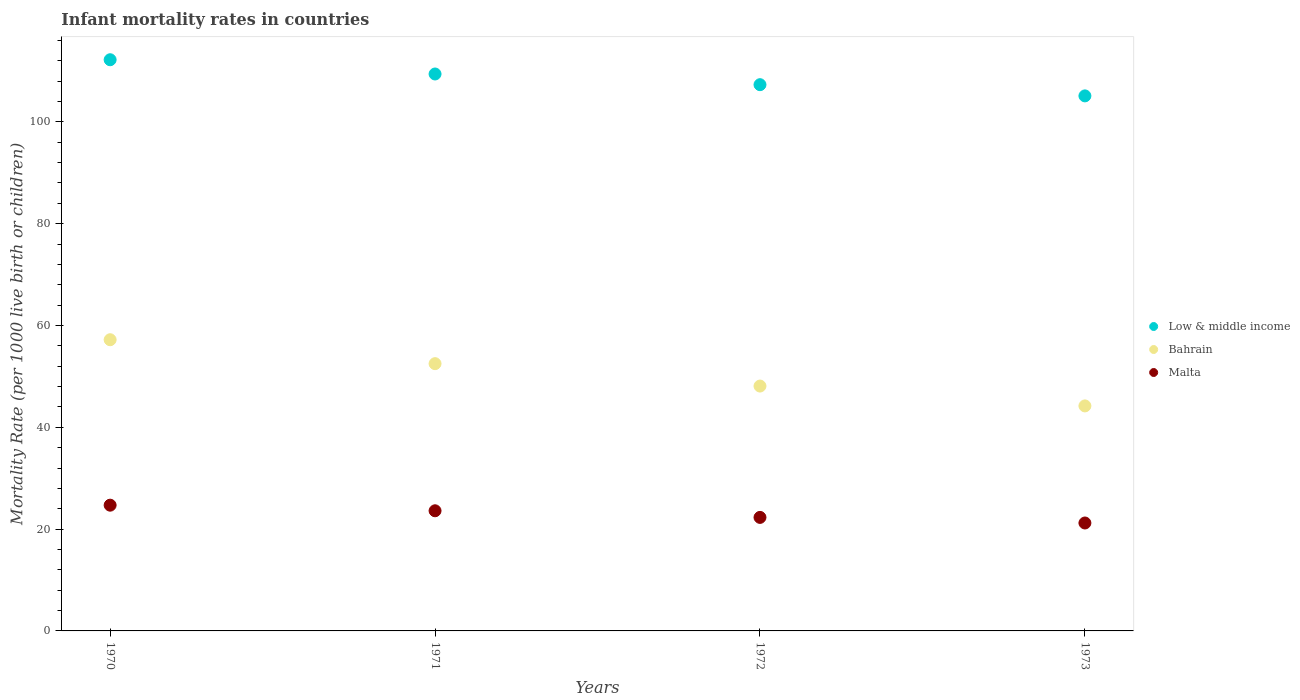How many different coloured dotlines are there?
Provide a short and direct response. 3. What is the infant mortality rate in Low & middle income in 1971?
Provide a succinct answer. 109.4. Across all years, what is the maximum infant mortality rate in Bahrain?
Your answer should be compact. 57.2. Across all years, what is the minimum infant mortality rate in Low & middle income?
Give a very brief answer. 105.1. In which year was the infant mortality rate in Low & middle income maximum?
Give a very brief answer. 1970. What is the total infant mortality rate in Low & middle income in the graph?
Your answer should be very brief. 434. What is the difference between the infant mortality rate in Malta in 1970 and that in 1972?
Make the answer very short. 2.4. What is the difference between the infant mortality rate in Bahrain in 1973 and the infant mortality rate in Malta in 1972?
Give a very brief answer. 21.9. What is the average infant mortality rate in Malta per year?
Offer a very short reply. 22.95. In the year 1973, what is the difference between the infant mortality rate in Low & middle income and infant mortality rate in Malta?
Provide a succinct answer. 83.9. What is the ratio of the infant mortality rate in Low & middle income in 1970 to that in 1971?
Offer a terse response. 1.03. Is the infant mortality rate in Low & middle income in 1971 less than that in 1972?
Ensure brevity in your answer.  No. Is the difference between the infant mortality rate in Low & middle income in 1970 and 1971 greater than the difference between the infant mortality rate in Malta in 1970 and 1971?
Provide a short and direct response. Yes. What is the difference between the highest and the second highest infant mortality rate in Malta?
Give a very brief answer. 1.1. What is the difference between the highest and the lowest infant mortality rate in Malta?
Offer a terse response. 3.5. In how many years, is the infant mortality rate in Low & middle income greater than the average infant mortality rate in Low & middle income taken over all years?
Provide a succinct answer. 2. Does the infant mortality rate in Malta monotonically increase over the years?
Provide a short and direct response. No. Is the infant mortality rate in Low & middle income strictly greater than the infant mortality rate in Malta over the years?
Give a very brief answer. Yes. Is the infant mortality rate in Bahrain strictly less than the infant mortality rate in Malta over the years?
Your answer should be compact. No. How many years are there in the graph?
Make the answer very short. 4. What is the difference between two consecutive major ticks on the Y-axis?
Offer a very short reply. 20. Does the graph contain any zero values?
Your answer should be very brief. No. Does the graph contain grids?
Give a very brief answer. No. What is the title of the graph?
Keep it short and to the point. Infant mortality rates in countries. What is the label or title of the Y-axis?
Give a very brief answer. Mortality Rate (per 1000 live birth or children). What is the Mortality Rate (per 1000 live birth or children) in Low & middle income in 1970?
Provide a short and direct response. 112.2. What is the Mortality Rate (per 1000 live birth or children) in Bahrain in 1970?
Your answer should be compact. 57.2. What is the Mortality Rate (per 1000 live birth or children) in Malta in 1970?
Provide a short and direct response. 24.7. What is the Mortality Rate (per 1000 live birth or children) of Low & middle income in 1971?
Your answer should be compact. 109.4. What is the Mortality Rate (per 1000 live birth or children) in Bahrain in 1971?
Provide a short and direct response. 52.5. What is the Mortality Rate (per 1000 live birth or children) in Malta in 1971?
Provide a short and direct response. 23.6. What is the Mortality Rate (per 1000 live birth or children) of Low & middle income in 1972?
Provide a succinct answer. 107.3. What is the Mortality Rate (per 1000 live birth or children) in Bahrain in 1972?
Offer a very short reply. 48.1. What is the Mortality Rate (per 1000 live birth or children) in Malta in 1972?
Your response must be concise. 22.3. What is the Mortality Rate (per 1000 live birth or children) of Low & middle income in 1973?
Keep it short and to the point. 105.1. What is the Mortality Rate (per 1000 live birth or children) in Bahrain in 1973?
Provide a succinct answer. 44.2. What is the Mortality Rate (per 1000 live birth or children) in Malta in 1973?
Keep it short and to the point. 21.2. Across all years, what is the maximum Mortality Rate (per 1000 live birth or children) of Low & middle income?
Offer a very short reply. 112.2. Across all years, what is the maximum Mortality Rate (per 1000 live birth or children) in Bahrain?
Keep it short and to the point. 57.2. Across all years, what is the maximum Mortality Rate (per 1000 live birth or children) of Malta?
Provide a short and direct response. 24.7. Across all years, what is the minimum Mortality Rate (per 1000 live birth or children) in Low & middle income?
Ensure brevity in your answer.  105.1. Across all years, what is the minimum Mortality Rate (per 1000 live birth or children) in Bahrain?
Your response must be concise. 44.2. Across all years, what is the minimum Mortality Rate (per 1000 live birth or children) of Malta?
Your answer should be compact. 21.2. What is the total Mortality Rate (per 1000 live birth or children) of Low & middle income in the graph?
Provide a succinct answer. 434. What is the total Mortality Rate (per 1000 live birth or children) in Bahrain in the graph?
Your answer should be compact. 202. What is the total Mortality Rate (per 1000 live birth or children) of Malta in the graph?
Give a very brief answer. 91.8. What is the difference between the Mortality Rate (per 1000 live birth or children) in Bahrain in 1970 and that in 1971?
Your answer should be compact. 4.7. What is the difference between the Mortality Rate (per 1000 live birth or children) in Low & middle income in 1970 and that in 1972?
Your response must be concise. 4.9. What is the difference between the Mortality Rate (per 1000 live birth or children) of Malta in 1970 and that in 1972?
Give a very brief answer. 2.4. What is the difference between the Mortality Rate (per 1000 live birth or children) in Low & middle income in 1970 and that in 1973?
Give a very brief answer. 7.1. What is the difference between the Mortality Rate (per 1000 live birth or children) in Bahrain in 1970 and that in 1973?
Your answer should be very brief. 13. What is the difference between the Mortality Rate (per 1000 live birth or children) in Malta in 1970 and that in 1973?
Offer a very short reply. 3.5. What is the difference between the Mortality Rate (per 1000 live birth or children) in Low & middle income in 1971 and that in 1972?
Your answer should be very brief. 2.1. What is the difference between the Mortality Rate (per 1000 live birth or children) of Bahrain in 1971 and that in 1972?
Offer a very short reply. 4.4. What is the difference between the Mortality Rate (per 1000 live birth or children) of Low & middle income in 1971 and that in 1973?
Provide a succinct answer. 4.3. What is the difference between the Mortality Rate (per 1000 live birth or children) of Malta in 1971 and that in 1973?
Your response must be concise. 2.4. What is the difference between the Mortality Rate (per 1000 live birth or children) of Low & middle income in 1972 and that in 1973?
Offer a very short reply. 2.2. What is the difference between the Mortality Rate (per 1000 live birth or children) in Malta in 1972 and that in 1973?
Provide a succinct answer. 1.1. What is the difference between the Mortality Rate (per 1000 live birth or children) of Low & middle income in 1970 and the Mortality Rate (per 1000 live birth or children) of Bahrain in 1971?
Your answer should be very brief. 59.7. What is the difference between the Mortality Rate (per 1000 live birth or children) of Low & middle income in 1970 and the Mortality Rate (per 1000 live birth or children) of Malta in 1971?
Offer a very short reply. 88.6. What is the difference between the Mortality Rate (per 1000 live birth or children) of Bahrain in 1970 and the Mortality Rate (per 1000 live birth or children) of Malta in 1971?
Provide a short and direct response. 33.6. What is the difference between the Mortality Rate (per 1000 live birth or children) in Low & middle income in 1970 and the Mortality Rate (per 1000 live birth or children) in Bahrain in 1972?
Keep it short and to the point. 64.1. What is the difference between the Mortality Rate (per 1000 live birth or children) of Low & middle income in 1970 and the Mortality Rate (per 1000 live birth or children) of Malta in 1972?
Give a very brief answer. 89.9. What is the difference between the Mortality Rate (per 1000 live birth or children) of Bahrain in 1970 and the Mortality Rate (per 1000 live birth or children) of Malta in 1972?
Offer a terse response. 34.9. What is the difference between the Mortality Rate (per 1000 live birth or children) of Low & middle income in 1970 and the Mortality Rate (per 1000 live birth or children) of Malta in 1973?
Provide a short and direct response. 91. What is the difference between the Mortality Rate (per 1000 live birth or children) in Bahrain in 1970 and the Mortality Rate (per 1000 live birth or children) in Malta in 1973?
Your answer should be compact. 36. What is the difference between the Mortality Rate (per 1000 live birth or children) in Low & middle income in 1971 and the Mortality Rate (per 1000 live birth or children) in Bahrain in 1972?
Your answer should be compact. 61.3. What is the difference between the Mortality Rate (per 1000 live birth or children) in Low & middle income in 1971 and the Mortality Rate (per 1000 live birth or children) in Malta in 1972?
Keep it short and to the point. 87.1. What is the difference between the Mortality Rate (per 1000 live birth or children) in Bahrain in 1971 and the Mortality Rate (per 1000 live birth or children) in Malta in 1972?
Your answer should be very brief. 30.2. What is the difference between the Mortality Rate (per 1000 live birth or children) in Low & middle income in 1971 and the Mortality Rate (per 1000 live birth or children) in Bahrain in 1973?
Provide a succinct answer. 65.2. What is the difference between the Mortality Rate (per 1000 live birth or children) in Low & middle income in 1971 and the Mortality Rate (per 1000 live birth or children) in Malta in 1973?
Your answer should be compact. 88.2. What is the difference between the Mortality Rate (per 1000 live birth or children) of Bahrain in 1971 and the Mortality Rate (per 1000 live birth or children) of Malta in 1973?
Ensure brevity in your answer.  31.3. What is the difference between the Mortality Rate (per 1000 live birth or children) of Low & middle income in 1972 and the Mortality Rate (per 1000 live birth or children) of Bahrain in 1973?
Make the answer very short. 63.1. What is the difference between the Mortality Rate (per 1000 live birth or children) in Low & middle income in 1972 and the Mortality Rate (per 1000 live birth or children) in Malta in 1973?
Ensure brevity in your answer.  86.1. What is the difference between the Mortality Rate (per 1000 live birth or children) in Bahrain in 1972 and the Mortality Rate (per 1000 live birth or children) in Malta in 1973?
Provide a short and direct response. 26.9. What is the average Mortality Rate (per 1000 live birth or children) of Low & middle income per year?
Make the answer very short. 108.5. What is the average Mortality Rate (per 1000 live birth or children) in Bahrain per year?
Offer a very short reply. 50.5. What is the average Mortality Rate (per 1000 live birth or children) in Malta per year?
Provide a succinct answer. 22.95. In the year 1970, what is the difference between the Mortality Rate (per 1000 live birth or children) in Low & middle income and Mortality Rate (per 1000 live birth or children) in Bahrain?
Give a very brief answer. 55. In the year 1970, what is the difference between the Mortality Rate (per 1000 live birth or children) of Low & middle income and Mortality Rate (per 1000 live birth or children) of Malta?
Your response must be concise. 87.5. In the year 1970, what is the difference between the Mortality Rate (per 1000 live birth or children) in Bahrain and Mortality Rate (per 1000 live birth or children) in Malta?
Provide a short and direct response. 32.5. In the year 1971, what is the difference between the Mortality Rate (per 1000 live birth or children) in Low & middle income and Mortality Rate (per 1000 live birth or children) in Bahrain?
Keep it short and to the point. 56.9. In the year 1971, what is the difference between the Mortality Rate (per 1000 live birth or children) of Low & middle income and Mortality Rate (per 1000 live birth or children) of Malta?
Your answer should be very brief. 85.8. In the year 1971, what is the difference between the Mortality Rate (per 1000 live birth or children) of Bahrain and Mortality Rate (per 1000 live birth or children) of Malta?
Ensure brevity in your answer.  28.9. In the year 1972, what is the difference between the Mortality Rate (per 1000 live birth or children) in Low & middle income and Mortality Rate (per 1000 live birth or children) in Bahrain?
Your answer should be very brief. 59.2. In the year 1972, what is the difference between the Mortality Rate (per 1000 live birth or children) of Low & middle income and Mortality Rate (per 1000 live birth or children) of Malta?
Offer a very short reply. 85. In the year 1972, what is the difference between the Mortality Rate (per 1000 live birth or children) in Bahrain and Mortality Rate (per 1000 live birth or children) in Malta?
Your answer should be very brief. 25.8. In the year 1973, what is the difference between the Mortality Rate (per 1000 live birth or children) of Low & middle income and Mortality Rate (per 1000 live birth or children) of Bahrain?
Give a very brief answer. 60.9. In the year 1973, what is the difference between the Mortality Rate (per 1000 live birth or children) in Low & middle income and Mortality Rate (per 1000 live birth or children) in Malta?
Keep it short and to the point. 83.9. In the year 1973, what is the difference between the Mortality Rate (per 1000 live birth or children) in Bahrain and Mortality Rate (per 1000 live birth or children) in Malta?
Offer a very short reply. 23. What is the ratio of the Mortality Rate (per 1000 live birth or children) of Low & middle income in 1970 to that in 1971?
Your answer should be compact. 1.03. What is the ratio of the Mortality Rate (per 1000 live birth or children) of Bahrain in 1970 to that in 1971?
Keep it short and to the point. 1.09. What is the ratio of the Mortality Rate (per 1000 live birth or children) in Malta in 1970 to that in 1971?
Provide a short and direct response. 1.05. What is the ratio of the Mortality Rate (per 1000 live birth or children) in Low & middle income in 1970 to that in 1972?
Your response must be concise. 1.05. What is the ratio of the Mortality Rate (per 1000 live birth or children) in Bahrain in 1970 to that in 1972?
Give a very brief answer. 1.19. What is the ratio of the Mortality Rate (per 1000 live birth or children) of Malta in 1970 to that in 1972?
Your response must be concise. 1.11. What is the ratio of the Mortality Rate (per 1000 live birth or children) in Low & middle income in 1970 to that in 1973?
Offer a very short reply. 1.07. What is the ratio of the Mortality Rate (per 1000 live birth or children) in Bahrain in 1970 to that in 1973?
Provide a short and direct response. 1.29. What is the ratio of the Mortality Rate (per 1000 live birth or children) of Malta in 1970 to that in 1973?
Provide a short and direct response. 1.17. What is the ratio of the Mortality Rate (per 1000 live birth or children) of Low & middle income in 1971 to that in 1972?
Offer a very short reply. 1.02. What is the ratio of the Mortality Rate (per 1000 live birth or children) of Bahrain in 1971 to that in 1972?
Keep it short and to the point. 1.09. What is the ratio of the Mortality Rate (per 1000 live birth or children) of Malta in 1971 to that in 1972?
Give a very brief answer. 1.06. What is the ratio of the Mortality Rate (per 1000 live birth or children) of Low & middle income in 1971 to that in 1973?
Ensure brevity in your answer.  1.04. What is the ratio of the Mortality Rate (per 1000 live birth or children) of Bahrain in 1971 to that in 1973?
Give a very brief answer. 1.19. What is the ratio of the Mortality Rate (per 1000 live birth or children) in Malta in 1971 to that in 1973?
Provide a succinct answer. 1.11. What is the ratio of the Mortality Rate (per 1000 live birth or children) of Low & middle income in 1972 to that in 1973?
Your answer should be very brief. 1.02. What is the ratio of the Mortality Rate (per 1000 live birth or children) of Bahrain in 1972 to that in 1973?
Ensure brevity in your answer.  1.09. What is the ratio of the Mortality Rate (per 1000 live birth or children) of Malta in 1972 to that in 1973?
Your answer should be very brief. 1.05. What is the difference between the highest and the lowest Mortality Rate (per 1000 live birth or children) of Bahrain?
Your answer should be compact. 13. 